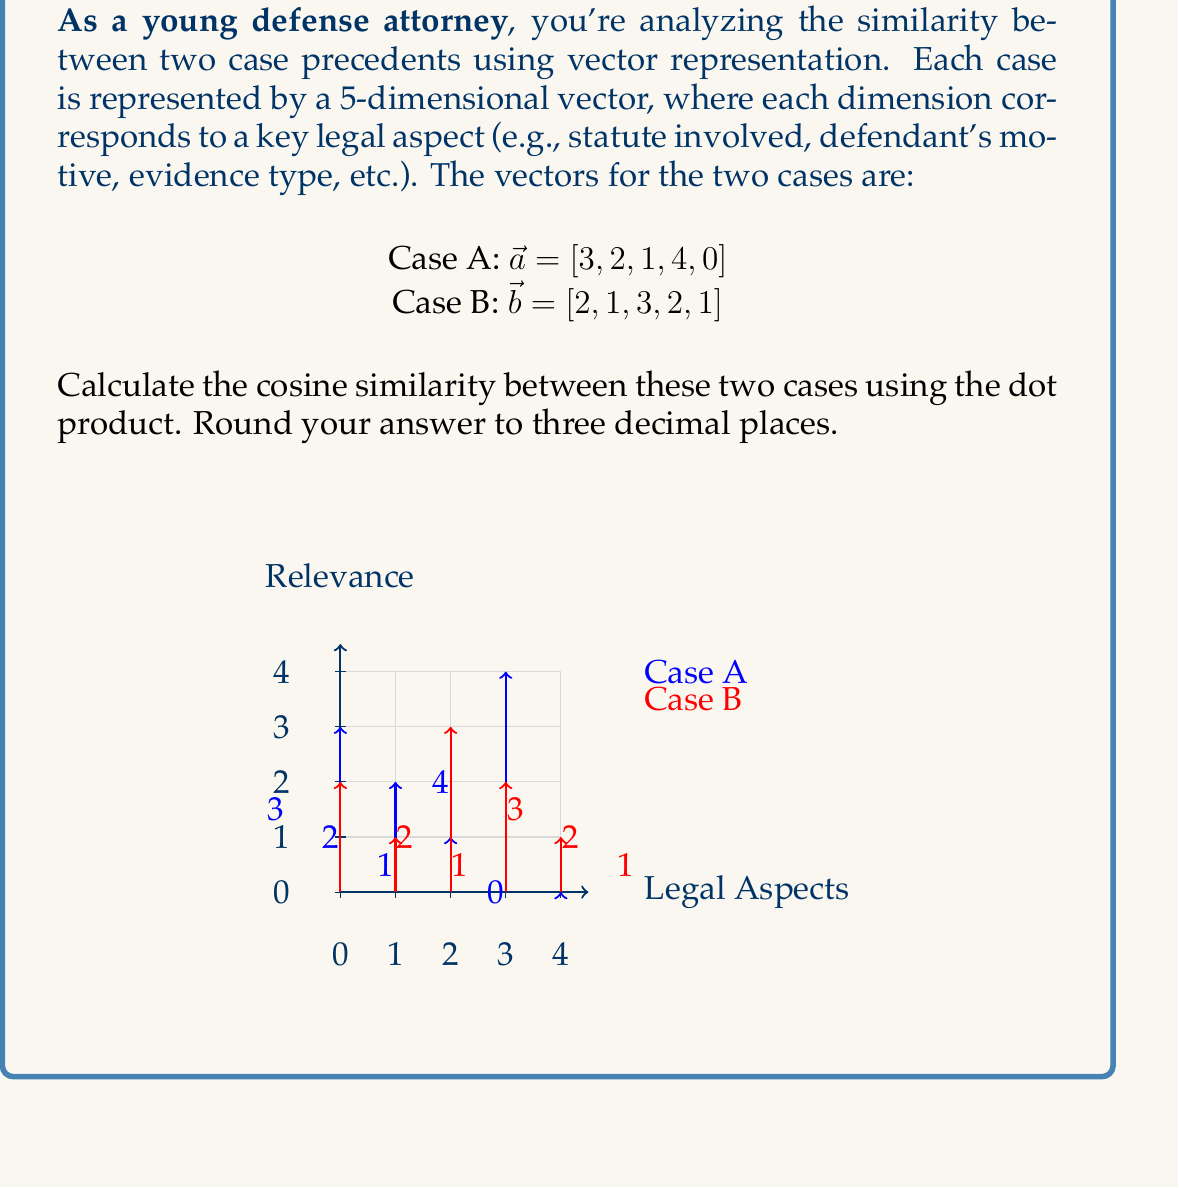What is the answer to this math problem? To calculate the cosine similarity between two vectors using the dot product, we follow these steps:

1) First, calculate the dot product of the two vectors:
   $$\vec{a} \cdot \vec{b} = (3 \times 2) + (2 \times 1) + (1 \times 3) + (4 \times 2) + (0 \times 1) = 6 + 2 + 3 + 8 + 0 = 19$$

2) Calculate the magnitudes of both vectors:
   $$|\vec{a}| = \sqrt{3^2 + 2^2 + 1^2 + 4^2 + 0^2} = \sqrt{9 + 4 + 1 + 16 + 0} = \sqrt{30}$$
   $$|\vec{b}| = \sqrt{2^2 + 1^2 + 3^2 + 2^2 + 1^2} = \sqrt{4 + 1 + 9 + 4 + 1} = \sqrt{19}$$

3) The cosine similarity is given by the formula:
   $$\cos \theta = \frac{\vec{a} \cdot \vec{b}}{|\vec{a}||\vec{b}|}$$

4) Substitute the values:
   $$\cos \theta = \frac{19}{\sqrt{30} \times \sqrt{19}}$$

5) Calculate:
   $$\cos \theta = \frac{19}{\sqrt{570}} \approx 0.795$$

6) Round to three decimal places: 0.795

This value ranges from -1 to 1, where 1 indicates perfect similarity, 0 indicates no similarity, and -1 indicates perfect dissimilarity. A value of 0.795 suggests a high degree of similarity between the two case precedents.
Answer: 0.795 